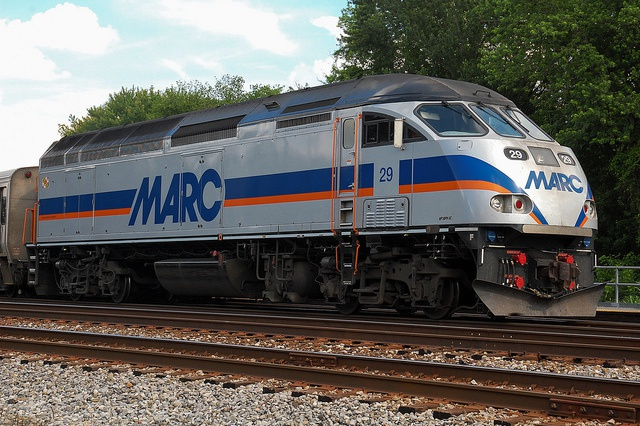Describe the objects in this image and their specific colors. I can see a train in lightblue, black, gray, darkgray, and navy tones in this image. 